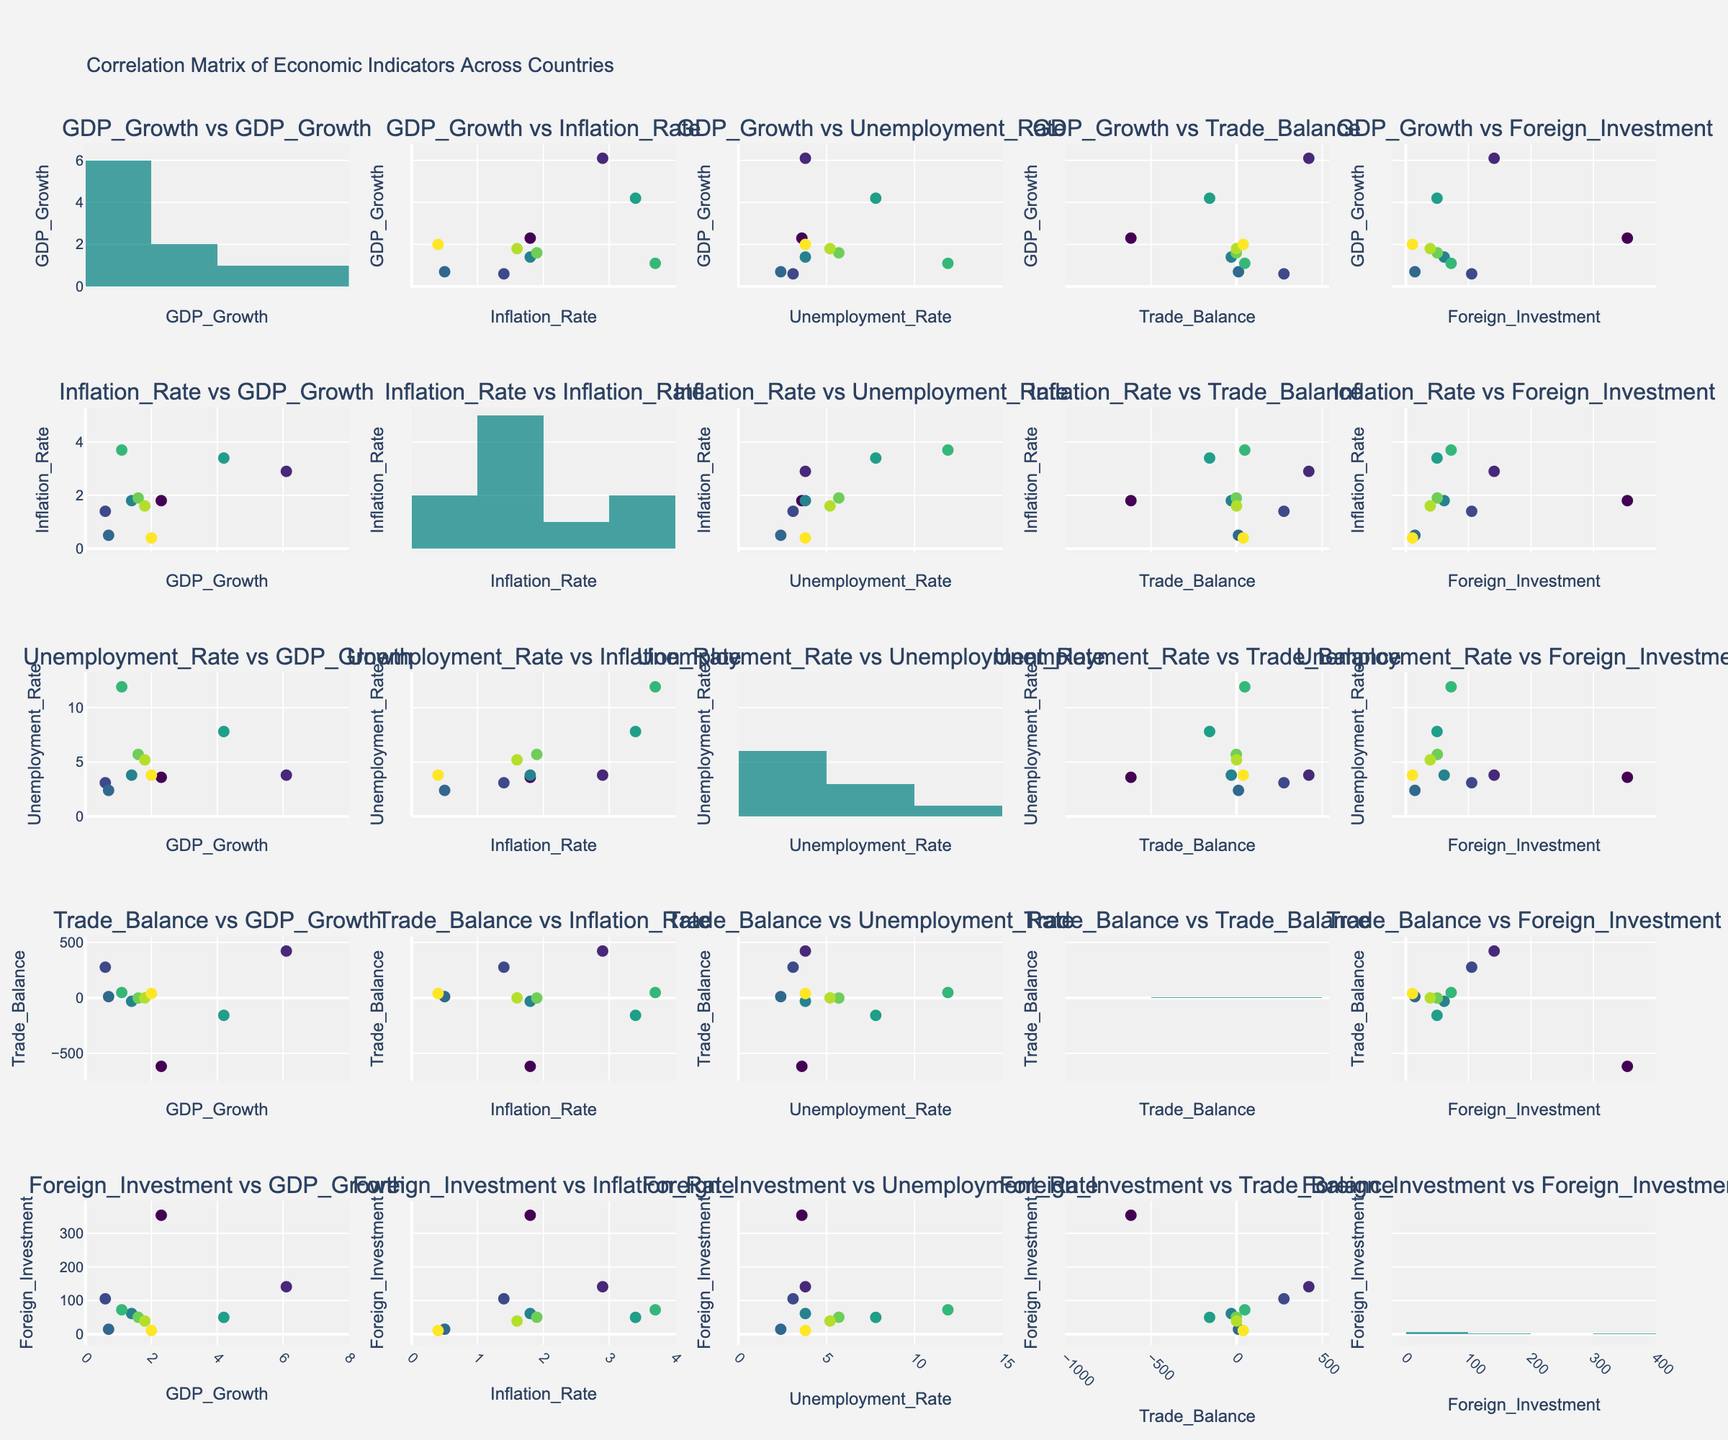Which country has the highest GDP growth rate? Look at the scatter plots or histogram related to GDP Growth. The point representing China is at the highest position on the GDP Growth axis.
Answer: China What is the average unemployment rate among all countries? Examine the Unemployment Rate data points. Add all unemployment rates: (3.6 + 3.8 + 3.1 + 2.4 + 3.8 + 7.8 + 11.9 + 5.7 + 5.2 + 3.8) and then divide by the number of countries (10): (51.1 / 10).
Answer: 5.11 How does the inflation rate of Japan compare with that of Brazil? Find the scatter plot or histogram showing the Inflation Rate. Japan has an inflation rate of 0.5, while Brazil has an inflation rate of 3.7.
Answer: Japan's inflation rate is lower than Brazil's Which two indicators have the strongest visual correlation? Check the scatter plots for the densest pattern of points forming a linear trend. The scatter plot shows the connection between GDP Growth and Inflation Rate which seems to show strong positive correlation.
Answer: GDP Growth and Inflation Rate What is the trade balance of South Korea? Locate South Korea on any of the scatter plots involving Trade Balance. The point representing South Korea has a Trade Balance of 38.9.
Answer: 38.9 Which country had the lowest foreign investment? Refer to any plot or histogram involving Foreign Investment. South Korea has the lowest value at 10.6.
Answer: South Korea What is the visible correlation between the unemployment rate and foreign investment? Check the scatter plot contrasting Unemployment Rate and Foreign Investment. The pattern is visually random, indicating no strong obvious correlation.
Answer: No strong correlation What is the sum of the trade balance values of the USA, UK, and India? Find plots involving Trade Balance to identify values: USA: -616.8, UK: -30.7, and India: -157.4. Sum these values (-616.8 + (-30.7) + (-157.4)).
Answer: -804.9 Which two countries have the closest GDP growth rates? Find scatter plots or histograms involving GDP Growth to compare countries visually. USA (2.3) and South Korea (2.0) have similar GDP growth rates.
Answer: USA and South Korea What is the trade balance and foreign investment for Canada? Locate Canada in the relevant scatter plots or histograms for Trade Balance and Foreign Investment. Trade Balance is -1.5 and Foreign Investment is 50.3.
Answer: Trade Balance: -1.5, Foreign Investment: 50.3 